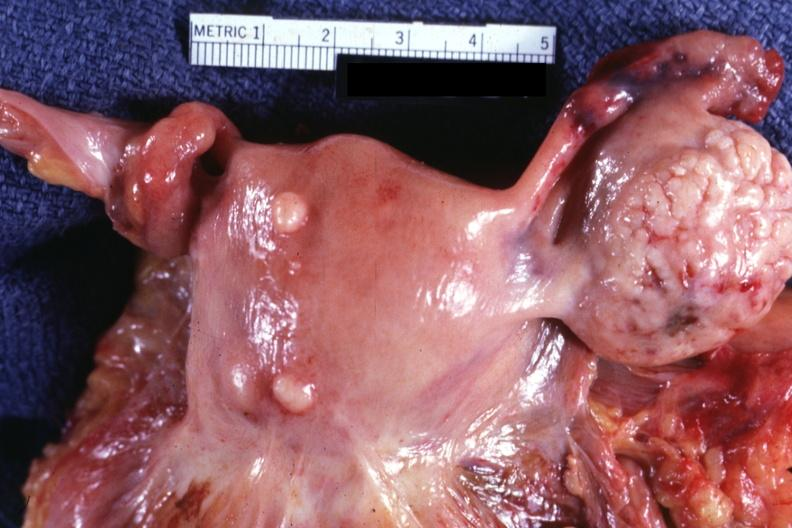what is in photo?
Answer the question using a single word or phrase. Normal ovary 